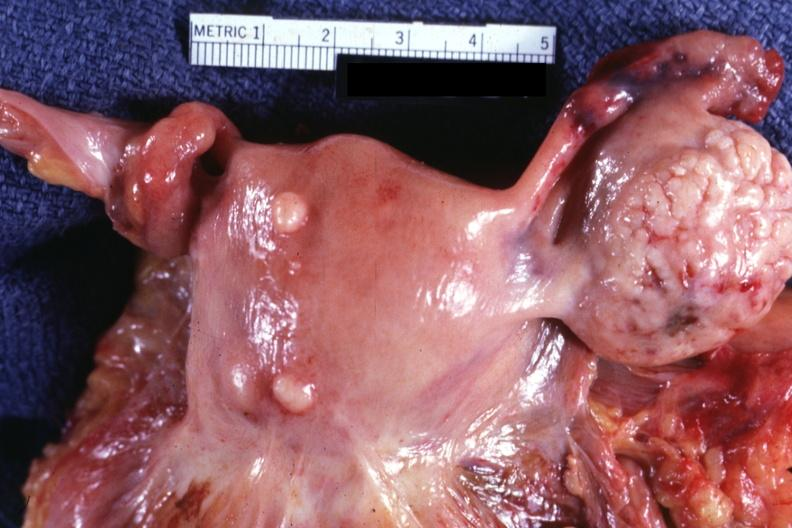what is in photo?
Answer the question using a single word or phrase. Normal ovary 